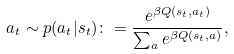Convert formula to latex. <formula><loc_0><loc_0><loc_500><loc_500>a _ { t } \sim p ( a _ { t } | s _ { t } ) \colon = \frac { e ^ { \beta Q ( s _ { t } , a _ { t } ) } } { \sum _ { a } e ^ { \beta Q ( s _ { t } , a ) } } ,</formula> 